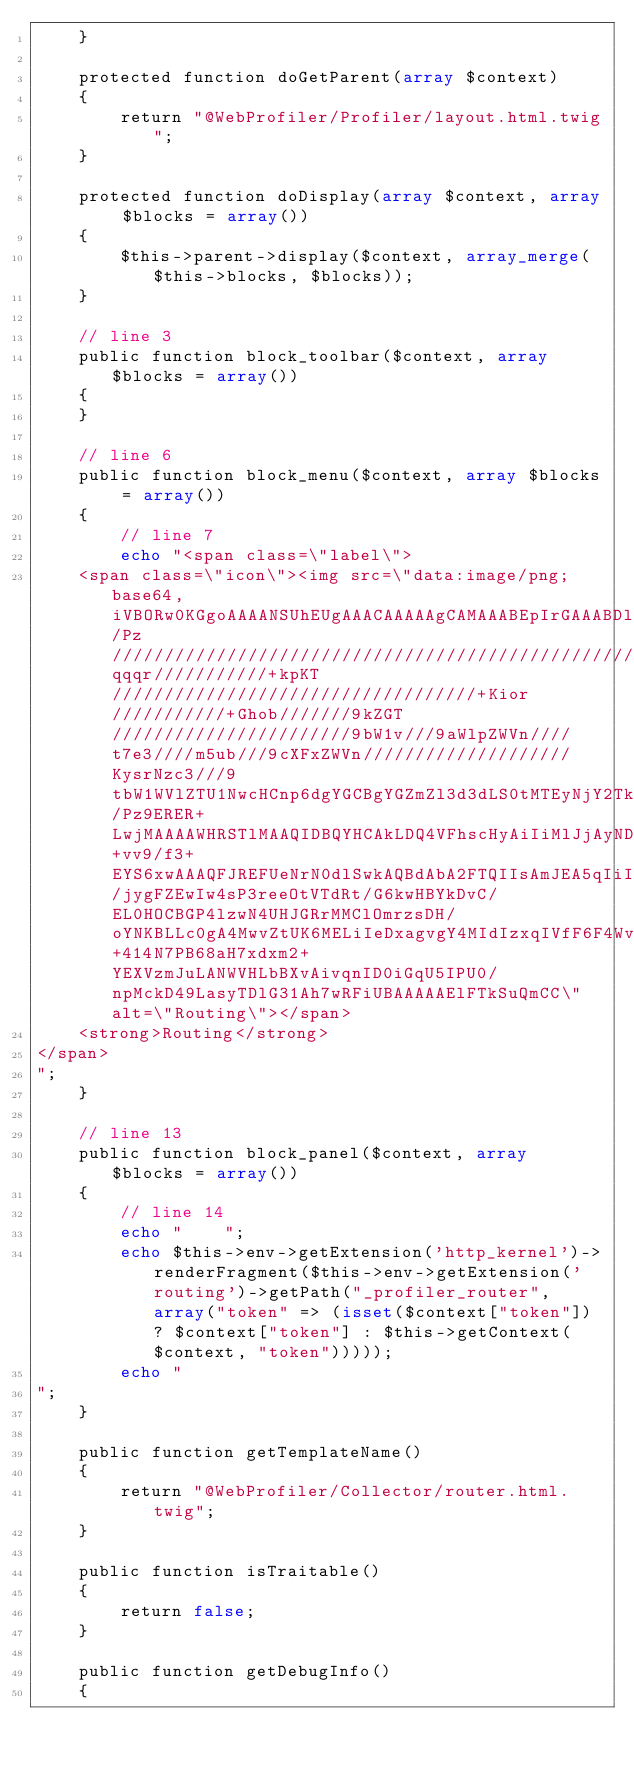<code> <loc_0><loc_0><loc_500><loc_500><_PHP_>    }

    protected function doGetParent(array $context)
    {
        return "@WebProfiler/Profiler/layout.html.twig";
    }

    protected function doDisplay(array $context, array $blocks = array())
    {
        $this->parent->display($context, array_merge($this->blocks, $blocks));
    }

    // line 3
    public function block_toolbar($context, array $blocks = array())
    {
    }

    // line 6
    public function block_menu($context, array $blocks = array())
    {
        // line 7
        echo "<span class=\"label\">
    <span class=\"icon\"><img src=\"data:image/png;base64,iVBORw0KGgoAAAANSUhEUgAAACAAAAAgCAMAAABEpIrGAAABDlBMVEU/Pz////////////////////////////////////////////////////////////////////+qqqr///////////+kpKT///////////////////////////////////+Kior///////////+Ghob///////9kZGT///////////////////////9bW1v///9aWlpZWVn////t7e3////m5ub///9cXFxZWVn////////////////////KysrNzc3///9tbW1WVlZTU1NwcHCnp6dgYGCBgYGZmZl3d3dLS0tMTEyNjY2Tk5NJSUlFRUVERERZWVlCQkJVVVVAQEBCQkJUVFRVVVU/Pz9ERER+LwjMAAAAWHRSTlMAAQIDBQYHCAkLDQ4VFhscHyAiIiMlJjAyNDY3ODk9P0BAREpMTlBdXl9rb3BzdHl6gICChIyPlaOmqKuusLm6v8HFzM3X2tzd4ePn6Onq8vb5+vv9/f3+EYS6xwAAAQFJREFUeNrN0dlSwkAQBdAbA2FTQIIsAmJEA5qIiIoim8oibigI0vz/jygFZEwIw4sP3reeOtVTdRt/G6kwHBYkDvC/EL0HOCBGP4lzwN4UHJGRrMMClOmrzsDH/oYNKBLLc0gA4MwvZtUK6MELiIeDxagvgY4MIdIzxqIVfF6F4WvSSjBpZHyQW6tBO7clIHjRNwO9dDdP5UQWAc9BfWICalSZZzfgBCBsHndNQIEl4o5Wna0s6UYZROcSO3IwMVsZVX9Xfe0CAF7VN+414N7PB68aH7xdxm2+YEXVzmJuLANWVHLbBXvAivqnID0iGqU5IPU0/npMckD49LasyTDlG31Ah7wRFiUBAAAAAElFTkSuQmCC\" alt=\"Routing\"></span>
    <strong>Routing</strong>
</span>
";
    }

    // line 13
    public function block_panel($context, array $blocks = array())
    {
        // line 14
        echo "    ";
        echo $this->env->getExtension('http_kernel')->renderFragment($this->env->getExtension('routing')->getPath("_profiler_router", array("token" => (isset($context["token"]) ? $context["token"] : $this->getContext($context, "token")))));
        echo "
";
    }

    public function getTemplateName()
    {
        return "@WebProfiler/Collector/router.html.twig";
    }

    public function isTraitable()
    {
        return false;
    }

    public function getDebugInfo()
    {</code> 